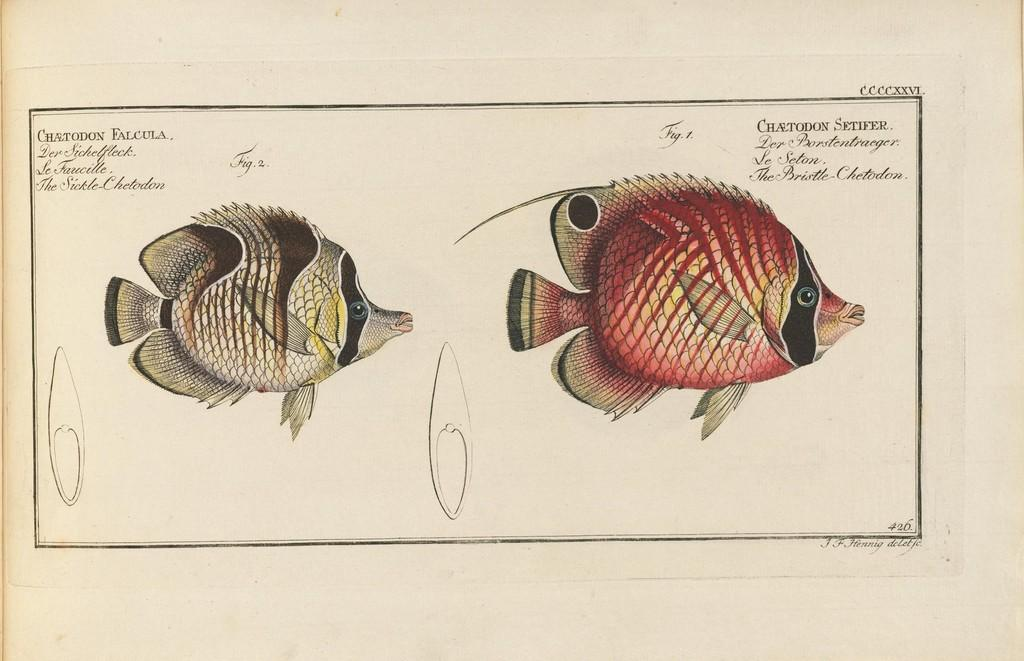What type of animals are depicted in the pictures in the image? There are pictures of fishes in the image. What else can be seen on the image besides the pictures of fishes? There is text visible on the image. How do the dolls compare to the fishes in the image? There are no dolls present in the image, so it is not possible to make a comparison. 